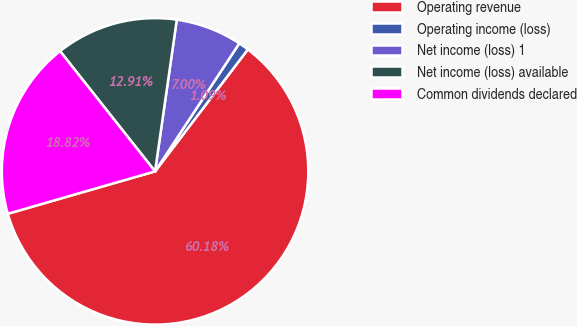Convert chart. <chart><loc_0><loc_0><loc_500><loc_500><pie_chart><fcel>Operating revenue<fcel>Operating income (loss)<fcel>Net income (loss) 1<fcel>Net income (loss) available<fcel>Common dividends declared<nl><fcel>60.19%<fcel>1.09%<fcel>7.0%<fcel>12.91%<fcel>18.82%<nl></chart> 